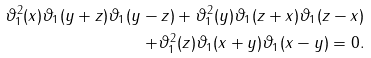Convert formula to latex. <formula><loc_0><loc_0><loc_500><loc_500>\vartheta _ { 1 } ^ { 2 } ( x ) \vartheta _ { 1 } ( y + z ) \vartheta _ { 1 } ( y - z ) + \vartheta _ { 1 } ^ { 2 } ( y ) \vartheta _ { 1 } ( z + x ) \vartheta _ { 1 } ( z - x ) \\ + \vartheta _ { 1 } ^ { 2 } ( z ) \vartheta _ { 1 } ( x + y ) \vartheta _ { 1 } ( x - y ) = 0 .</formula> 